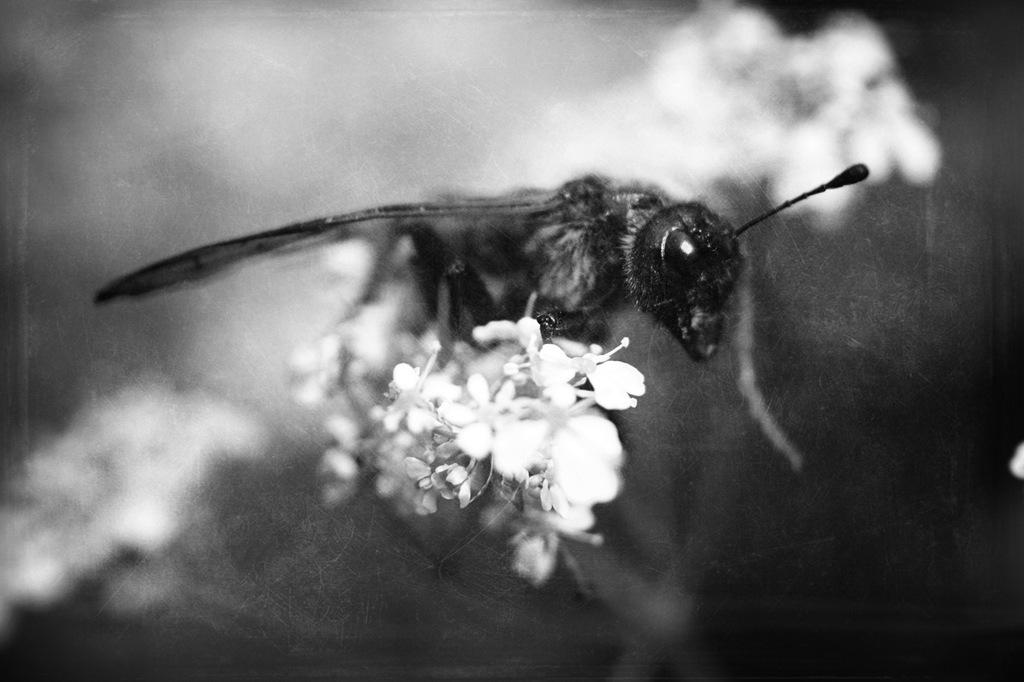What type of creature can be seen in the image? There is an insect in the image. What is the insect sitting on? The insect is on white color flowers. How would you describe the background of the image? The background of the image is blurred. What color scheme is used in the image? The image is black and white. How does the insect maintain its balance while falling in the image? There is no indication that the insect is falling in the image, and therefore the concept of balance is not applicable. 